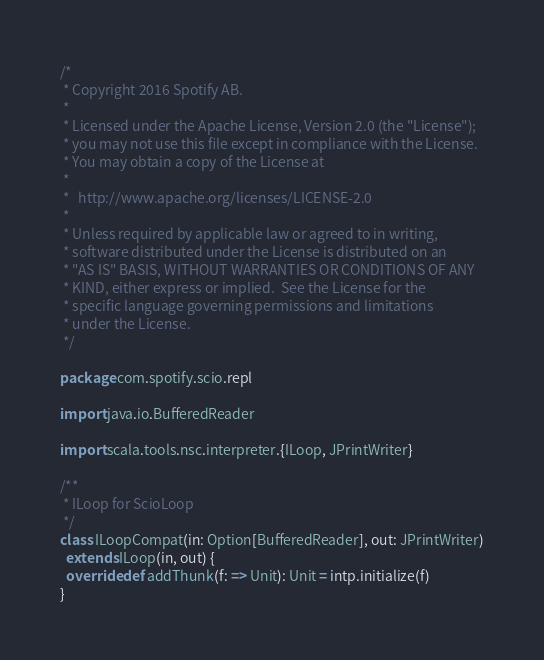Convert code to text. <code><loc_0><loc_0><loc_500><loc_500><_Scala_>/*
 * Copyright 2016 Spotify AB.
 *
 * Licensed under the Apache License, Version 2.0 (the "License");
 * you may not use this file except in compliance with the License.
 * You may obtain a copy of the License at
 *
 *   http://www.apache.org/licenses/LICENSE-2.0
 *
 * Unless required by applicable law or agreed to in writing,
 * software distributed under the License is distributed on an
 * "AS IS" BASIS, WITHOUT WARRANTIES OR CONDITIONS OF ANY
 * KIND, either express or implied.  See the License for the
 * specific language governing permissions and limitations
 * under the License.
 */

package com.spotify.scio.repl

import java.io.BufferedReader

import scala.tools.nsc.interpreter.{ILoop, JPrintWriter}

/**
 * ILoop for ScioLoop
 */
class ILoopCompat(in: Option[BufferedReader], out: JPrintWriter)
  extends ILoop(in, out) {
  override def addThunk(f: => Unit): Unit = intp.initialize(f)
}
</code> 